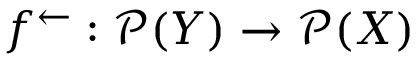Convert formula to latex. <formula><loc_0><loc_0><loc_500><loc_500>f ^ { \leftarrow } \colon { \mathcal { P } } ( Y ) \rightarrow { \mathcal { P } } ( X )</formula> 